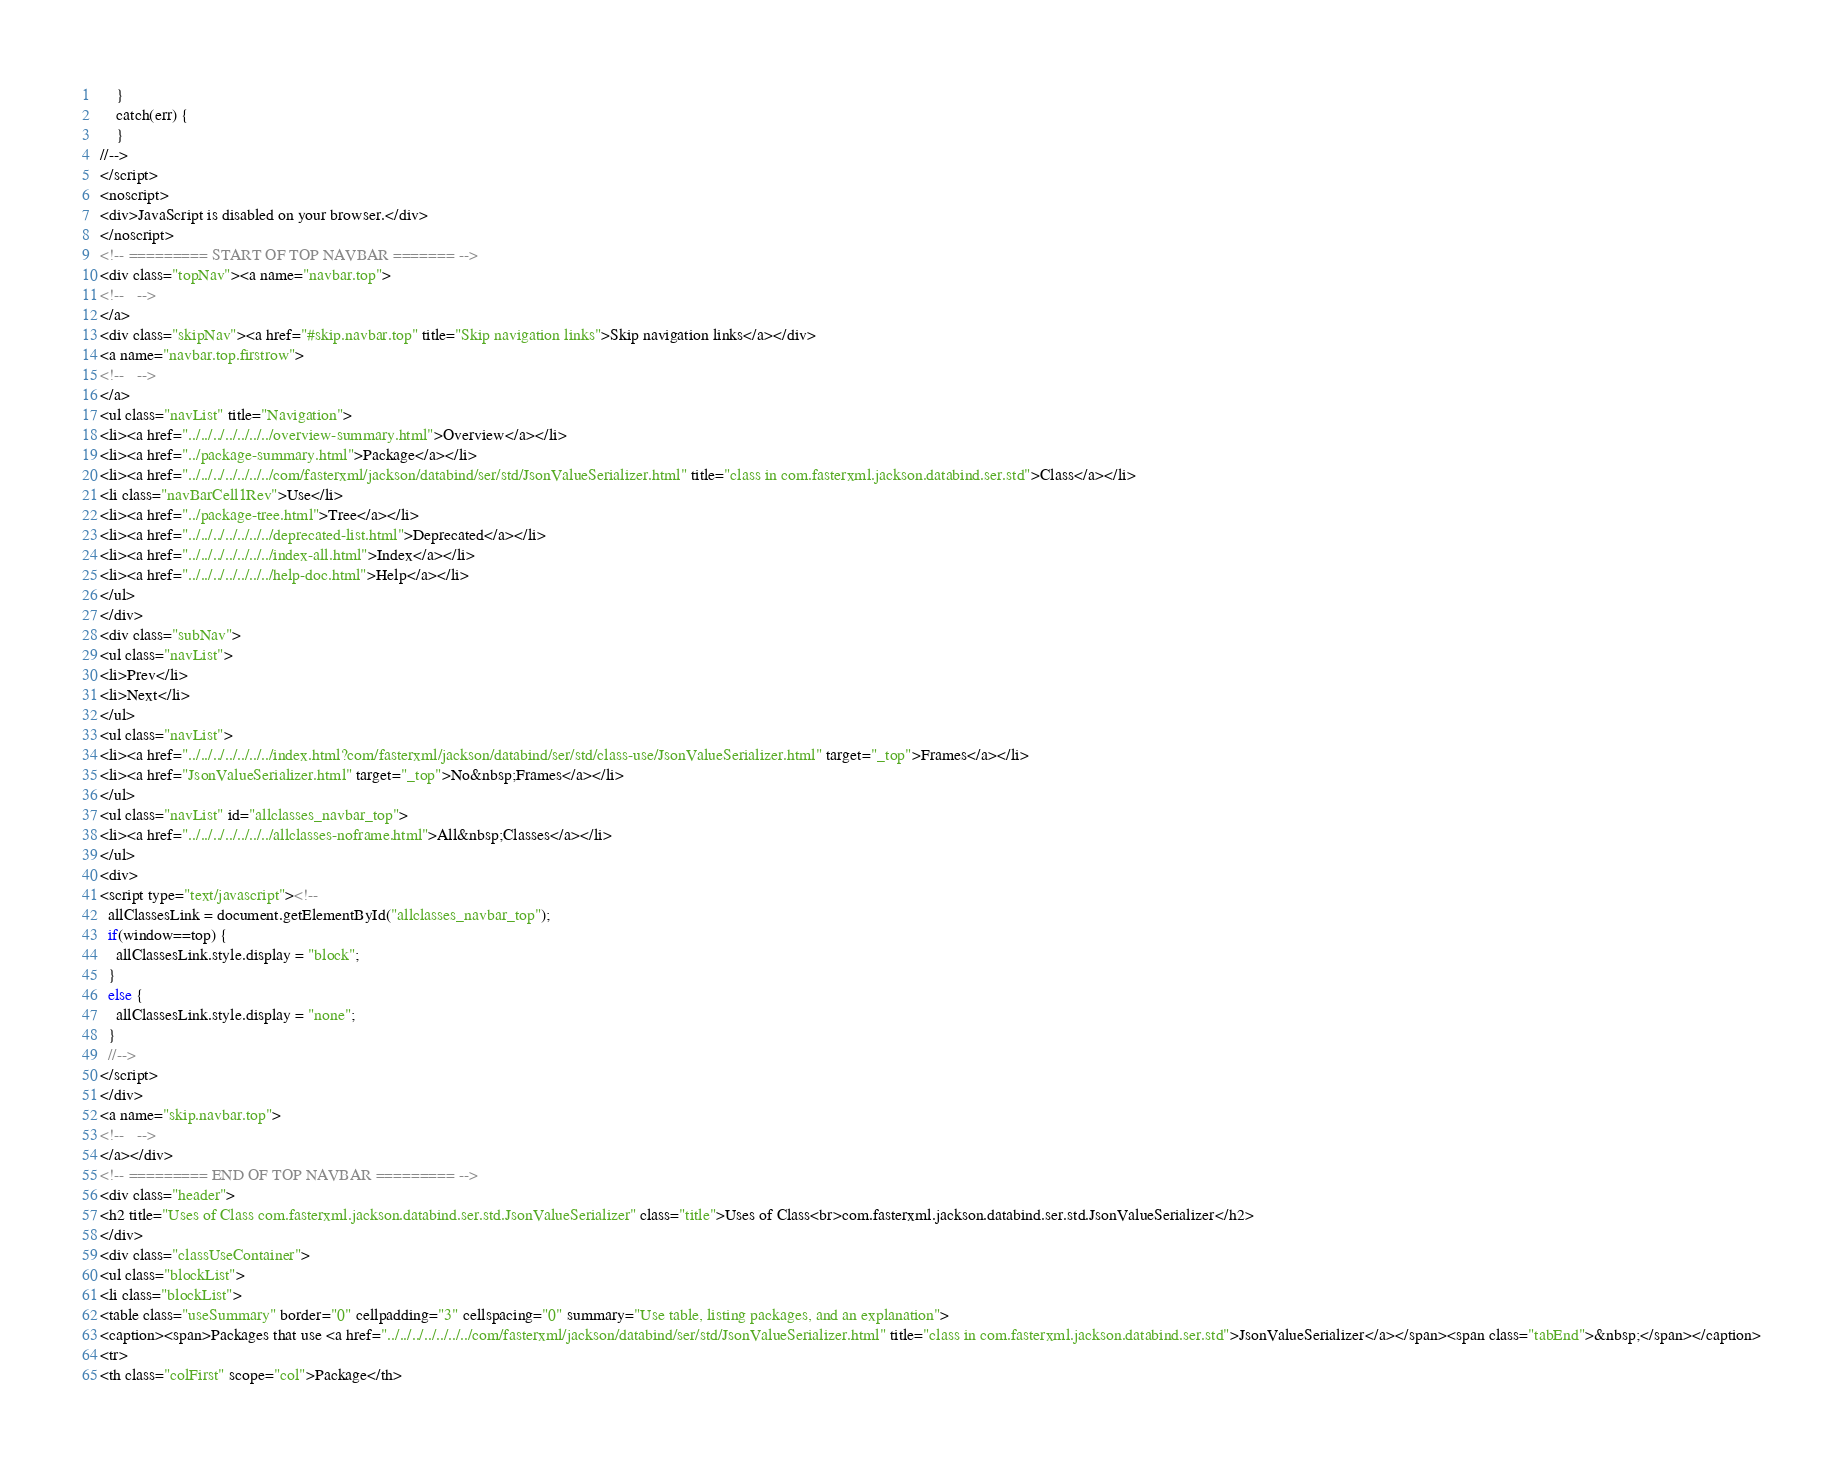Convert code to text. <code><loc_0><loc_0><loc_500><loc_500><_HTML_>    }
    catch(err) {
    }
//-->
</script>
<noscript>
<div>JavaScript is disabled on your browser.</div>
</noscript>
<!-- ========= START OF TOP NAVBAR ======= -->
<div class="topNav"><a name="navbar.top">
<!--   -->
</a>
<div class="skipNav"><a href="#skip.navbar.top" title="Skip navigation links">Skip navigation links</a></div>
<a name="navbar.top.firstrow">
<!--   -->
</a>
<ul class="navList" title="Navigation">
<li><a href="../../../../../../../overview-summary.html">Overview</a></li>
<li><a href="../package-summary.html">Package</a></li>
<li><a href="../../../../../../../com/fasterxml/jackson/databind/ser/std/JsonValueSerializer.html" title="class in com.fasterxml.jackson.databind.ser.std">Class</a></li>
<li class="navBarCell1Rev">Use</li>
<li><a href="../package-tree.html">Tree</a></li>
<li><a href="../../../../../../../deprecated-list.html">Deprecated</a></li>
<li><a href="../../../../../../../index-all.html">Index</a></li>
<li><a href="../../../../../../../help-doc.html">Help</a></li>
</ul>
</div>
<div class="subNav">
<ul class="navList">
<li>Prev</li>
<li>Next</li>
</ul>
<ul class="navList">
<li><a href="../../../../../../../index.html?com/fasterxml/jackson/databind/ser/std/class-use/JsonValueSerializer.html" target="_top">Frames</a></li>
<li><a href="JsonValueSerializer.html" target="_top">No&nbsp;Frames</a></li>
</ul>
<ul class="navList" id="allclasses_navbar_top">
<li><a href="../../../../../../../allclasses-noframe.html">All&nbsp;Classes</a></li>
</ul>
<div>
<script type="text/javascript"><!--
  allClassesLink = document.getElementById("allclasses_navbar_top");
  if(window==top) {
    allClassesLink.style.display = "block";
  }
  else {
    allClassesLink.style.display = "none";
  }
  //-->
</script>
</div>
<a name="skip.navbar.top">
<!--   -->
</a></div>
<!-- ========= END OF TOP NAVBAR ========= -->
<div class="header">
<h2 title="Uses of Class com.fasterxml.jackson.databind.ser.std.JsonValueSerializer" class="title">Uses of Class<br>com.fasterxml.jackson.databind.ser.std.JsonValueSerializer</h2>
</div>
<div class="classUseContainer">
<ul class="blockList">
<li class="blockList">
<table class="useSummary" border="0" cellpadding="3" cellspacing="0" summary="Use table, listing packages, and an explanation">
<caption><span>Packages that use <a href="../../../../../../../com/fasterxml/jackson/databind/ser/std/JsonValueSerializer.html" title="class in com.fasterxml.jackson.databind.ser.std">JsonValueSerializer</a></span><span class="tabEnd">&nbsp;</span></caption>
<tr>
<th class="colFirst" scope="col">Package</th></code> 